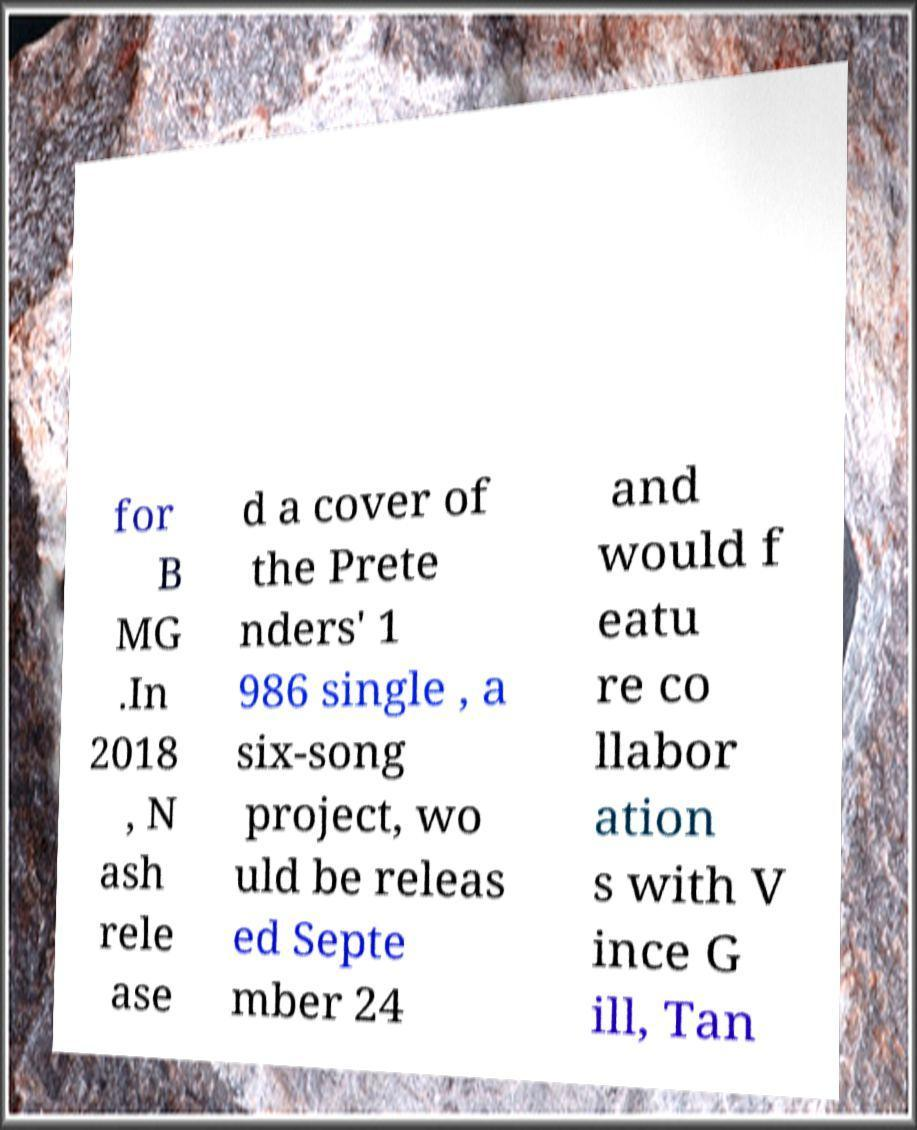I need the written content from this picture converted into text. Can you do that? for B MG .In 2018 , N ash rele ase d a cover of the Prete nders' 1 986 single , a six-song project, wo uld be releas ed Septe mber 24 and would f eatu re co llabor ation s with V ince G ill, Tan 